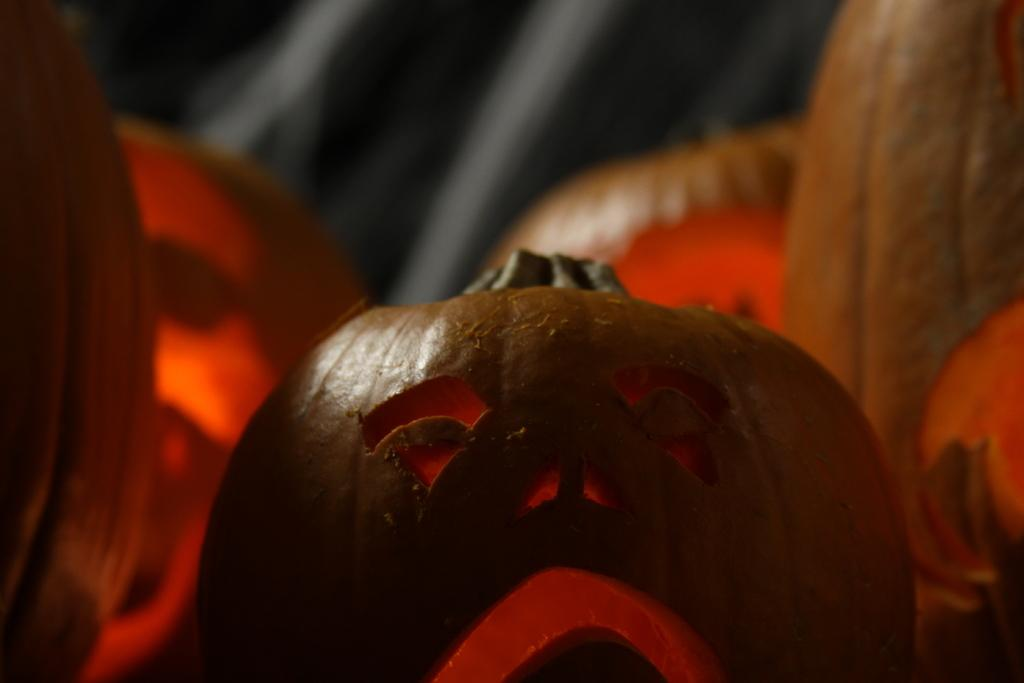What type of decorations are featured in the image? There are Halloween pumpkins in the image. What time of year might this image be associated with? This image might be associated with Halloween, given the presence of Halloween pumpkins. How are the pumpkins decorated or carved? The facts provided do not specify how the pumpkins are decorated or carved. How many goldfish can be seen swimming in the pumpkin in the image? There are no goldfish present in the image; it features Halloween pumpkins. 